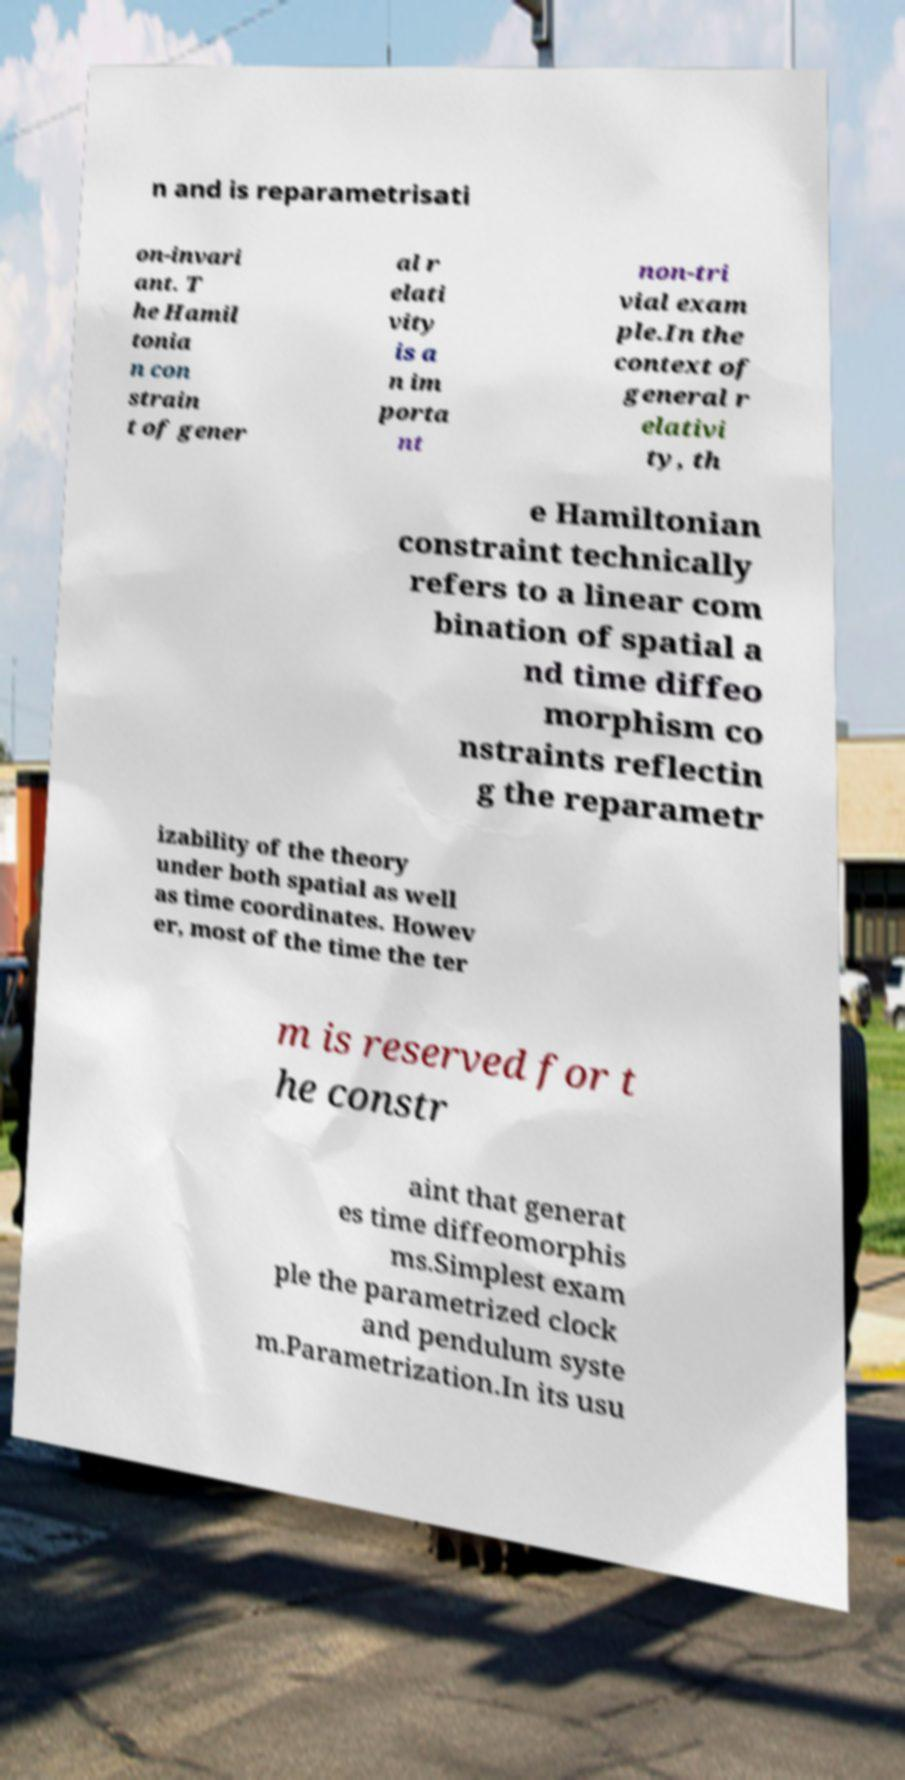What messages or text are displayed in this image? I need them in a readable, typed format. n and is reparametrisati on-invari ant. T he Hamil tonia n con strain t of gener al r elati vity is a n im porta nt non-tri vial exam ple.In the context of general r elativi ty, th e Hamiltonian constraint technically refers to a linear com bination of spatial a nd time diffeo morphism co nstraints reflectin g the reparametr izability of the theory under both spatial as well as time coordinates. Howev er, most of the time the ter m is reserved for t he constr aint that generat es time diffeomorphis ms.Simplest exam ple the parametrized clock and pendulum syste m.Parametrization.In its usu 